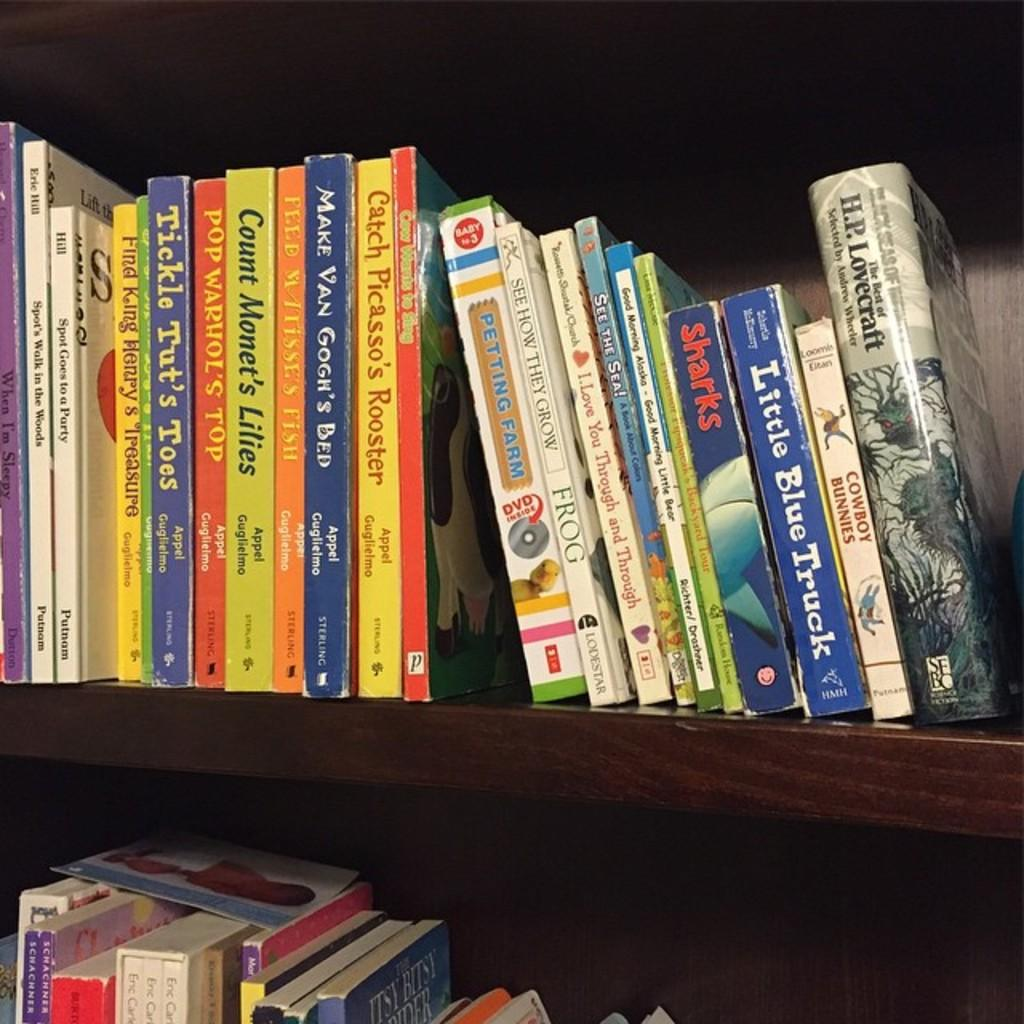What type of objects are in the shelf in the image? There are books in the shelf. Can you describe the appearance of the books? The books have various colors, including red, orange, yellow, and blue. What type of animal can be seen playing volleyball in the image? There is no animal or volleyball present in the image; it only features books on a shelf. 